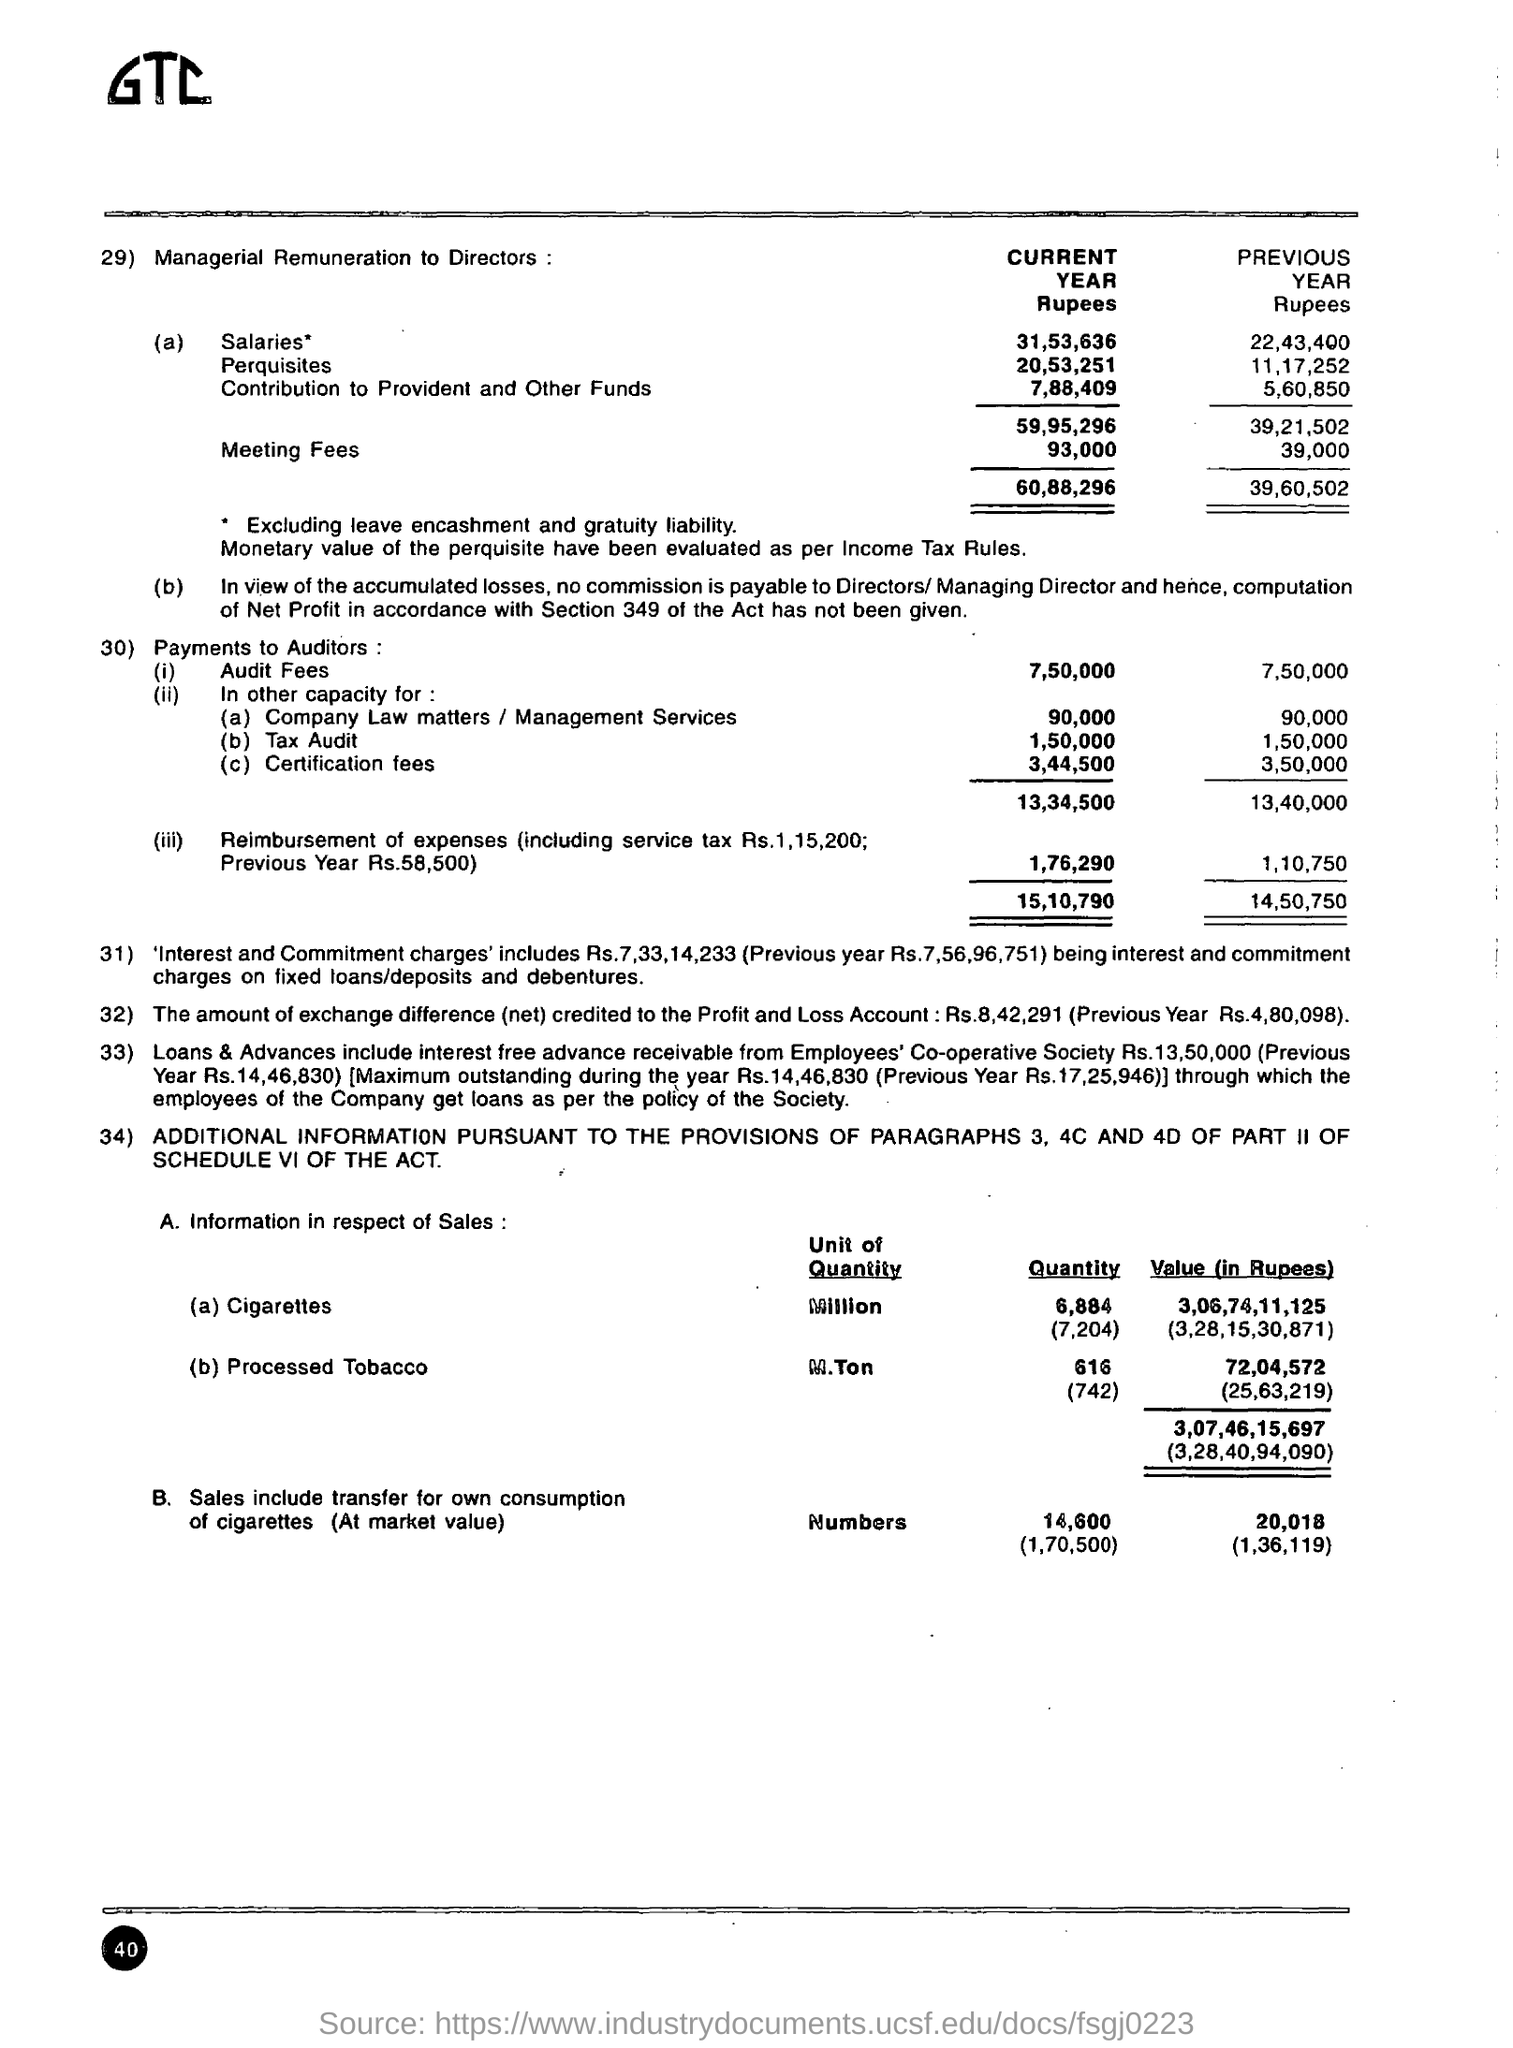What is the Current Year Meeting Fees?
Keep it short and to the point. 93,000. What is the Current Year Audit Fees?
Offer a terse response. 7,50,000. What is the Current Year Certification Fees?
Keep it short and to the point. 3,44,500. What are the previous year "Salaries"?
Give a very brief answer. 22,43,400. What is the Contribution to Provident and Other Funds for the Previous Year?
Ensure brevity in your answer.  5,60,850. What is the Contribution to Provident and Other Funds for the Current Year?
Offer a terse response. 7,88,409. 